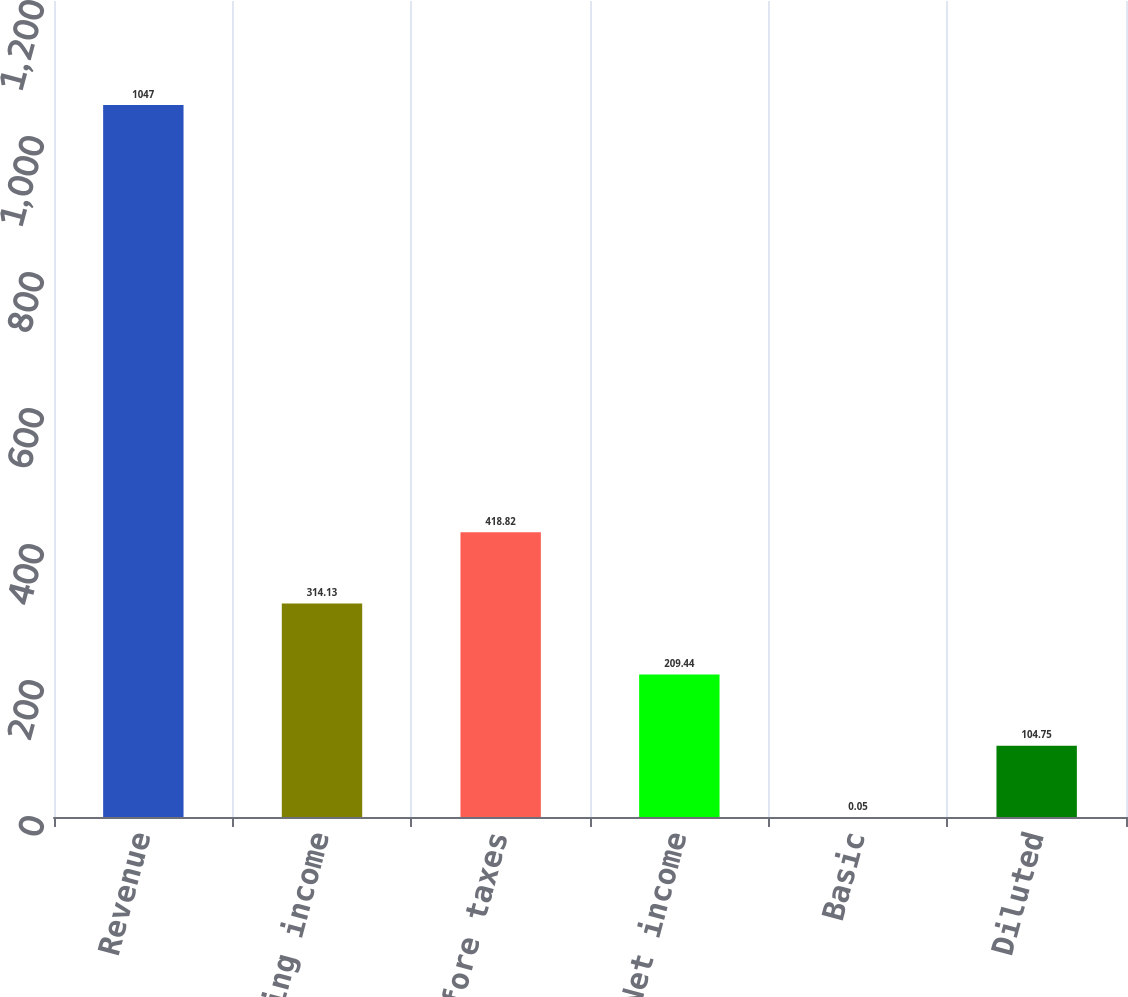<chart> <loc_0><loc_0><loc_500><loc_500><bar_chart><fcel>Revenue<fcel>Operating income<fcel>Income before taxes<fcel>Net income<fcel>Basic<fcel>Diluted<nl><fcel>1047<fcel>314.13<fcel>418.82<fcel>209.44<fcel>0.05<fcel>104.75<nl></chart> 